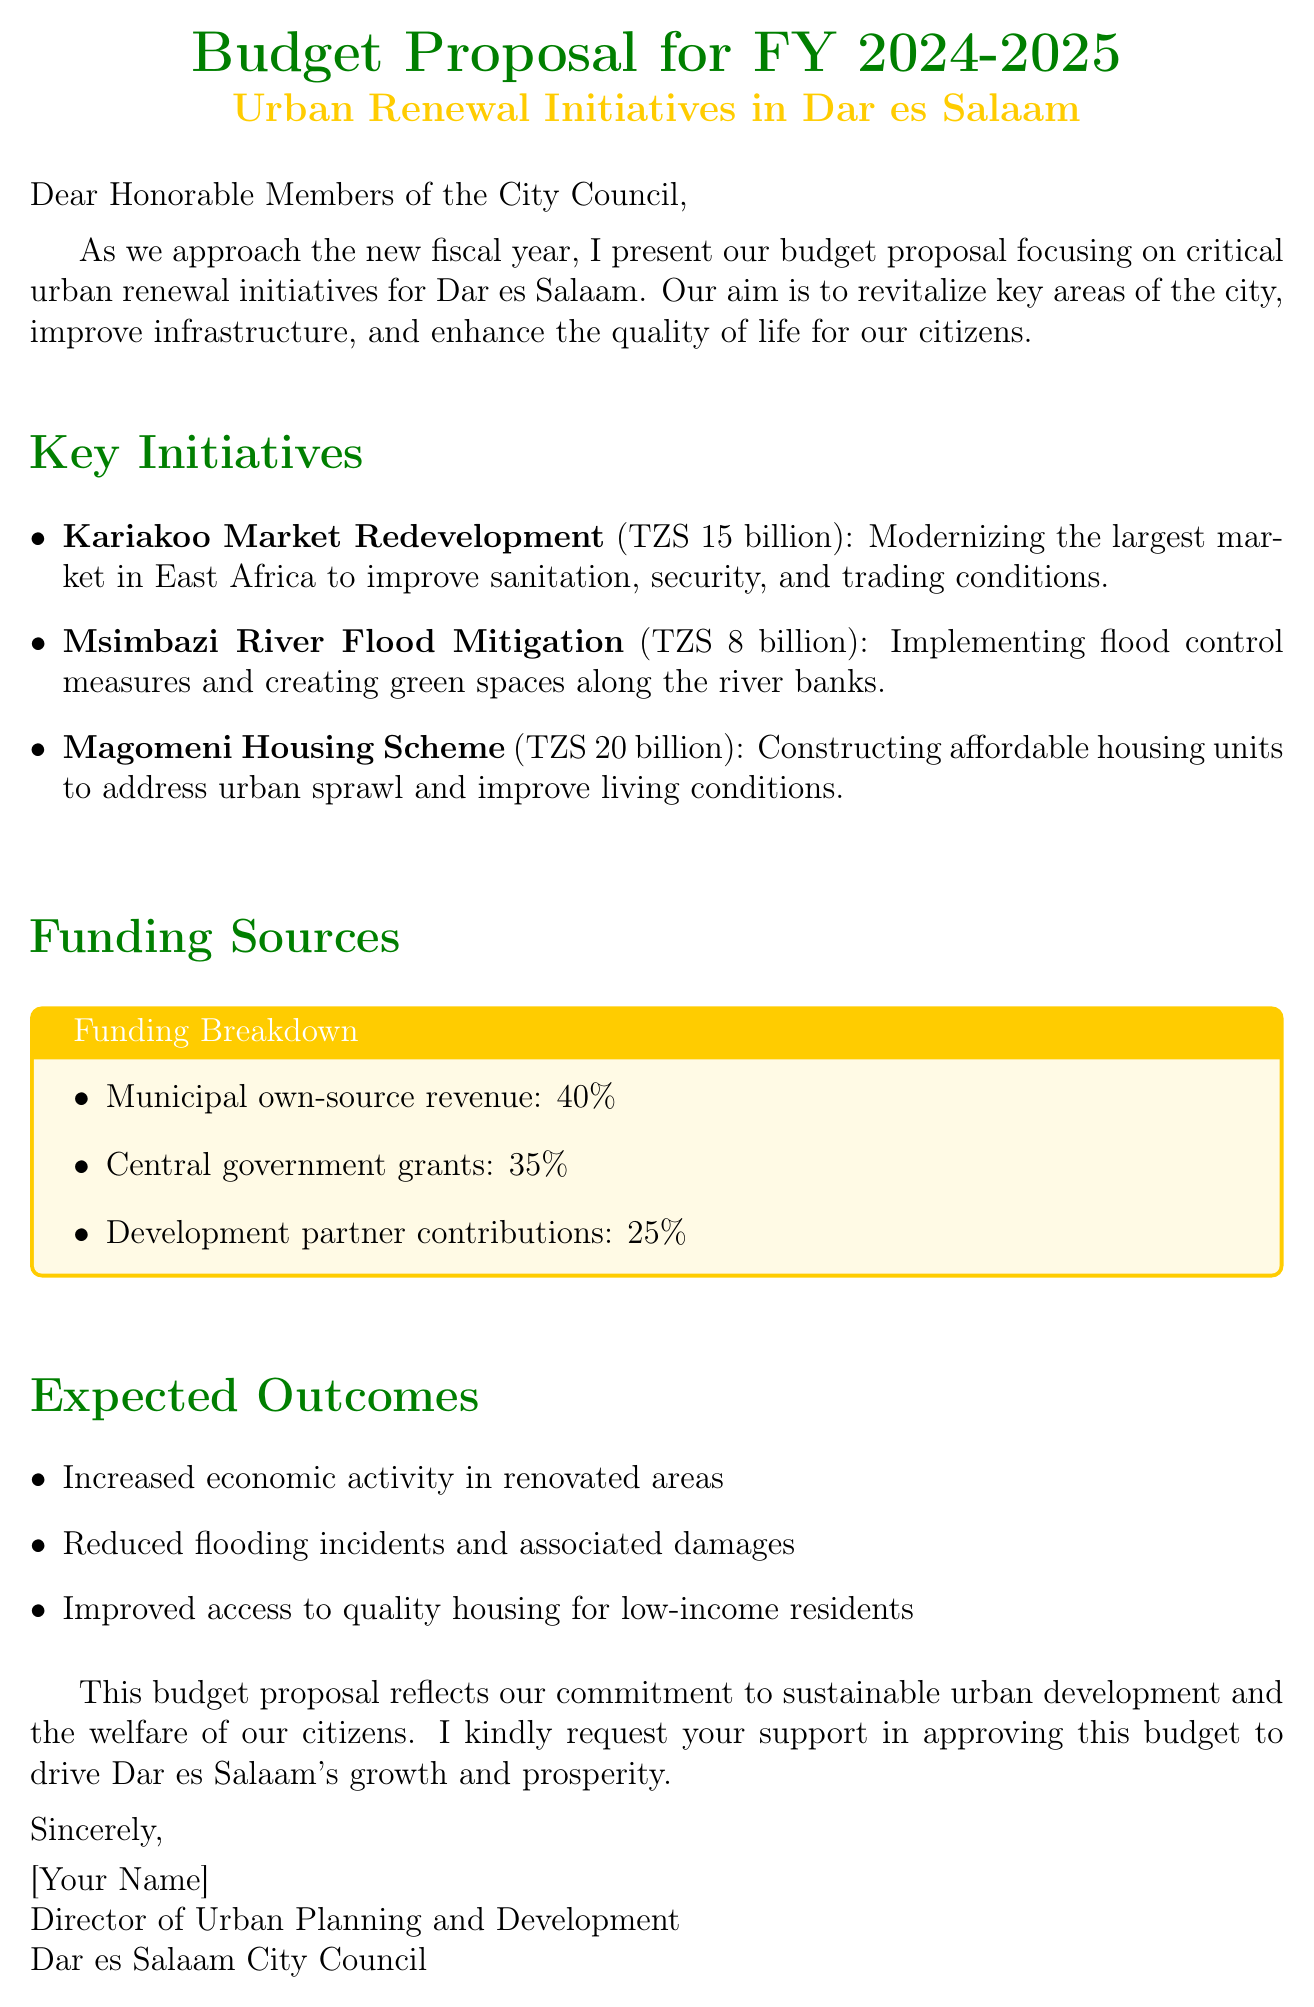what is the total budget for the Magomeni Housing Scheme? The total budget for the Magomeni Housing Scheme is specified directly in the document.
Answer: TZS 20 billion what is the budget allocation for the Kariakoo Market Redevelopment? The budget allocation for this project is provided in the list of key initiatives.
Answer: TZS 15 billion what percentage of funding comes from municipal own-source revenue? This information is detailed in the funding sources section.
Answer: 40% what are the expected outcomes of the budget proposal? The expected outcomes are listed in the document and summarize the overall goals.
Answer: Increased economic activity in renovated areas, Reduced flooding incidents and associated damages, Improved access to quality housing for low-income residents what is the focus of the budget proposal? The main focus of this budget proposal is outlined in the introduction of the document.
Answer: Urban renewal initiatives for Dar es Salaam who is the author of the budget proposal? The author's name is mentioned at the end of the document.
Answer: [Your Name] what is the main goal of the urban renewal initiatives? The goal is stated clearly in the introduction section of the document.
Answer: Revitalize key areas of the city, improve infrastructure, and enhance the quality of life for our citizens what funding source contributes 35% of the budget? This information is part of the breakdown of funding sources provided in the document.
Answer: Central government grants 